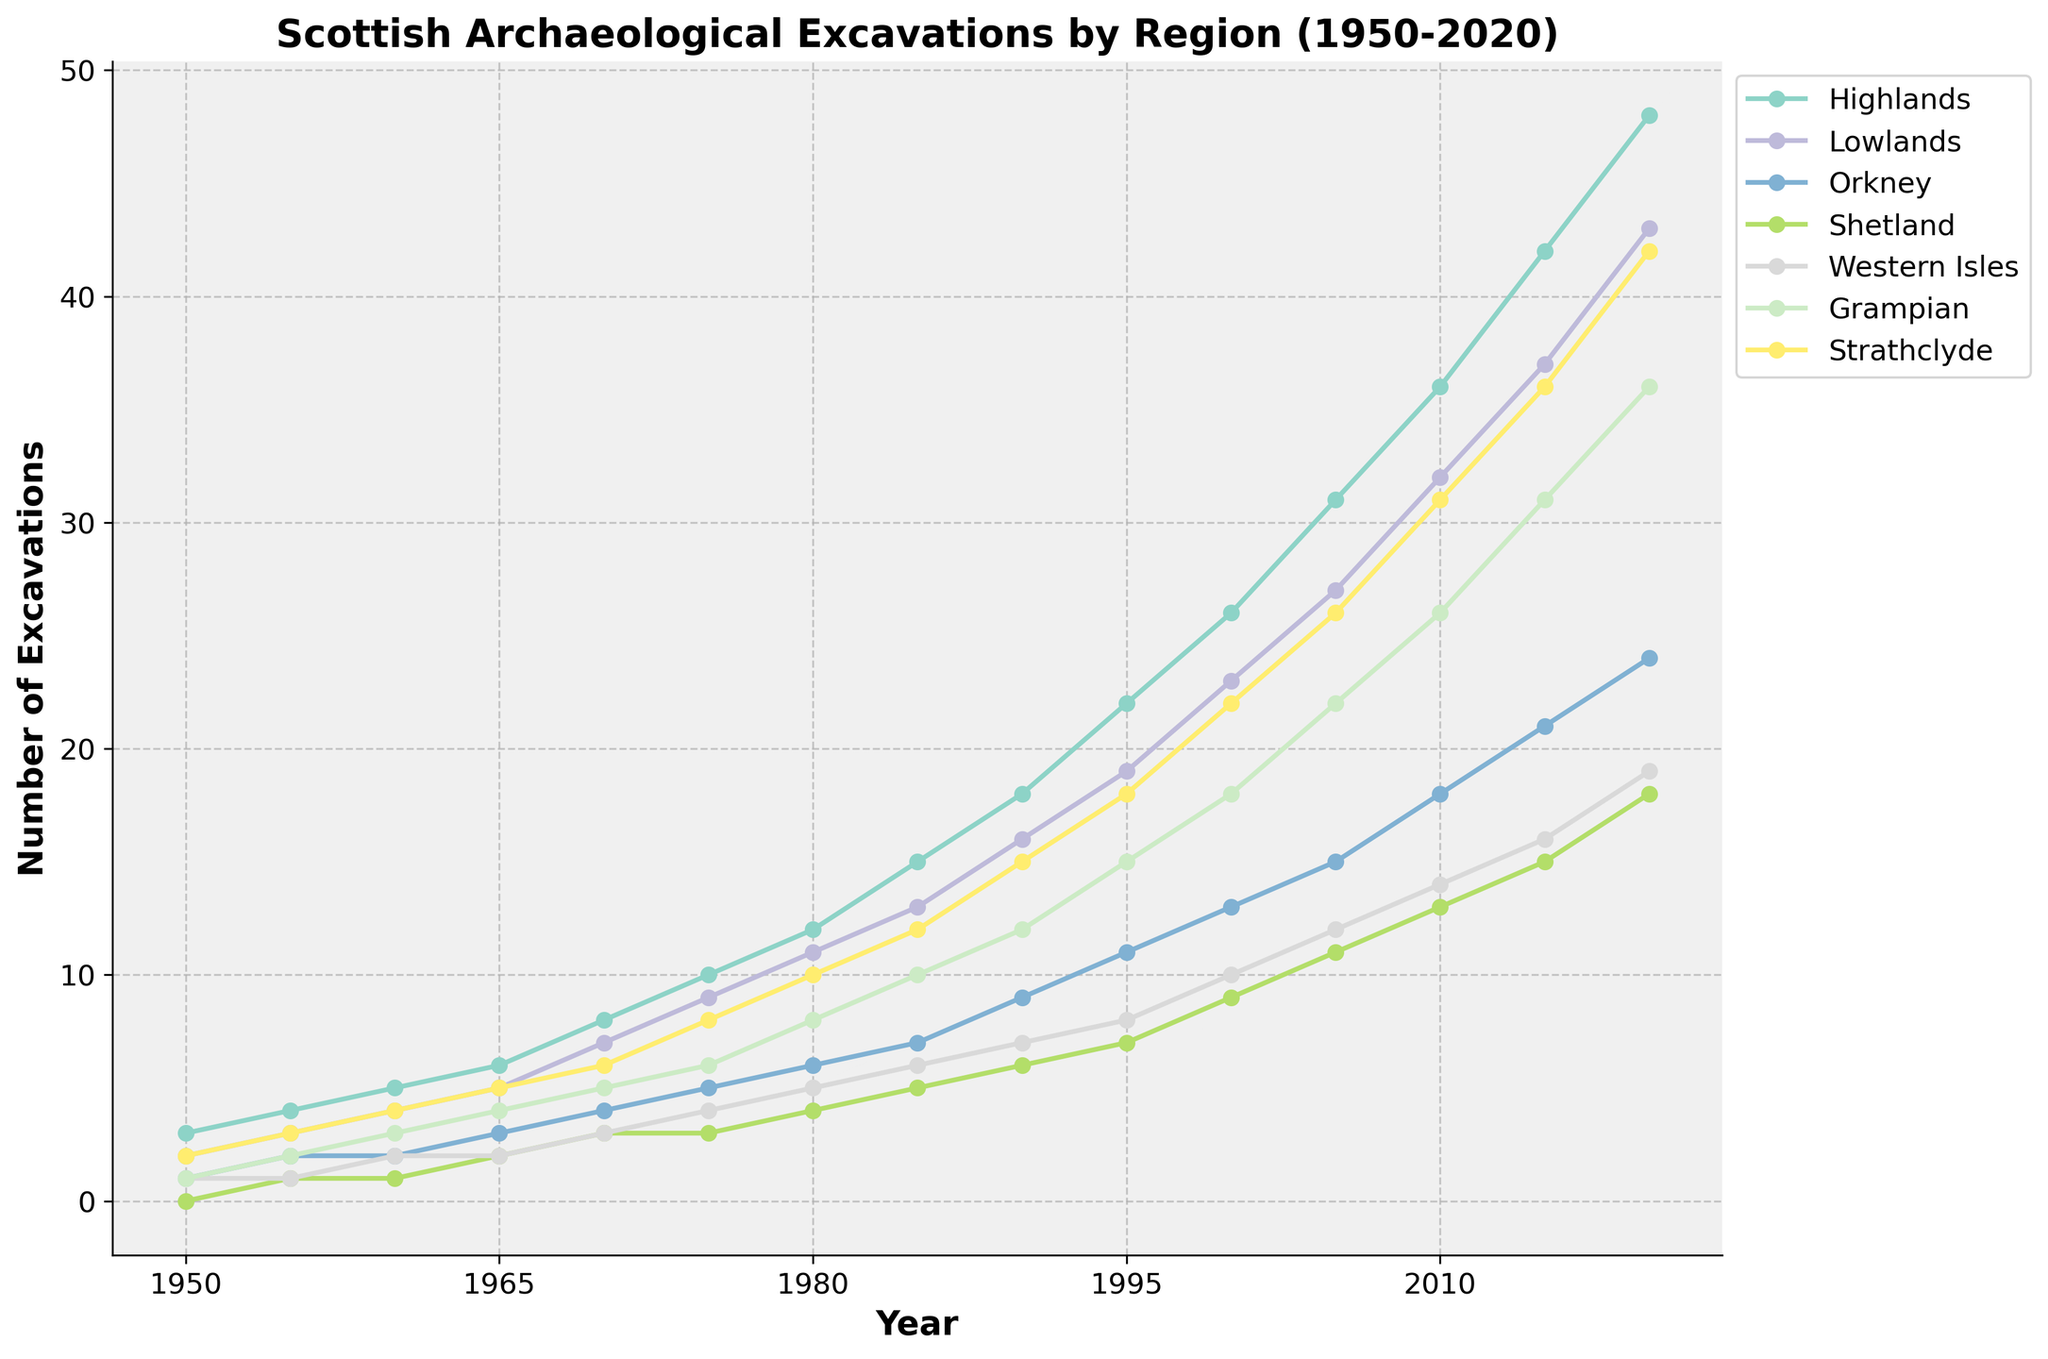How many excavation sites were recorded in the Highlands in the year 1975? Looking at the line corresponding to the Highlands in the figure and tracing it to the year 1975 on the x-axis, we find the value at the y-axis.
Answer: 10 Which region had the highest number of excavations in 2020? For each region, find the corresponding point on the graph for the year 2020 and compare their y-axis values. The region with the highest y-axis value in that year is the one with the most excavations.
Answer: Highlands How many more excavation sites were in Orkney than in Shetland in 1985? Identify the y-axis values for Orkney and Shetland in 1985 and subtract the value for Shetland from the value for Orkney. Orkney has 7 excavations and Shetland has 5, so 7 - 5 = 2.
Answer: 2 What is the average number of excavation sites in the Lowlands for the years 1960, 1970, and 1980? Find the y-axis values for the Lowlands in 1960, 1970, and 1980, sum them up, then divide by the number of years. The values are 4, 7, and 11. Sum = 4+7+11 = 22, and the average = 22/3 = 7.33.
Answer: 7.33 Which region had the smallest increase in the number of excavations from 1950 to 2020? Calculate the difference in the number of excavations between 2020 and 1950 for all regions, then identify the smallest difference. For example, the difference for Orkney is 24 - 1 = 23, for Shetland it is 18 - 0 = 18, etc.
Answer: Shetland What was the total number of excavations across all regions in the year 1990? Sum up the y-axis values for all regions in 1990. The values are: 18, 16, 9, 6, 7, 12, and 15. Sum = 18 + 16 + 9 + 6 + 7 + 12 + 15 = 83.
Answer: 83 By how much did the number of excavations in Strathclyde increase from 2000 to 2010? Find the difference in the number of excavations in Strathclyde between 2010 and 2000. The values are 31 (2010) and 22 (2000). Difference = 31 - 22 = 9.
Answer: 9 Which region saw a higher number of excavations in the year 1965, Highlands or Grampian? Compare the y-axis values for the Highlands and Grampian in 1965. Highlands has 6 and Grampian has 4. Since 6 > 4, Highlands had more excavations.
Answer: Highlands What trend do you observe in the number of excavations in the Western Isles region from 1950 to 2020? Observe the line corresponding to the Western Isles region from 1950 to 2020. The line shows a generally increasing trend from 1 in 1950 to 19 in 2020, indicating a consistent rise over the years.
Answer: Increasing trend 